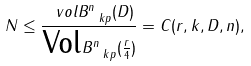Convert formula to latex. <formula><loc_0><loc_0><loc_500><loc_500>N \leq \frac { \ v o l B ^ { n } _ { \ k p } ( D ) } { \text {Vol} B ^ { n } _ { \ k p } ( \frac { r } { 4 } ) } = C ( r , k , D , n ) ,</formula> 